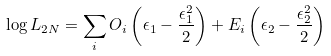Convert formula to latex. <formula><loc_0><loc_0><loc_500><loc_500>\log { L _ { 2 N } } = \sum _ { i } O _ { i } \left ( \epsilon _ { 1 } - \frac { \epsilon _ { 1 } ^ { 2 } } { 2 } \right ) + E _ { i } \left ( \epsilon _ { 2 } - \frac { \epsilon _ { 2 } ^ { 2 } } { 2 } \right )</formula> 